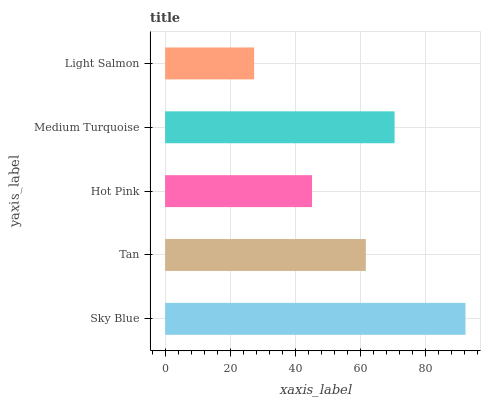Is Light Salmon the minimum?
Answer yes or no. Yes. Is Sky Blue the maximum?
Answer yes or no. Yes. Is Tan the minimum?
Answer yes or no. No. Is Tan the maximum?
Answer yes or no. No. Is Sky Blue greater than Tan?
Answer yes or no. Yes. Is Tan less than Sky Blue?
Answer yes or no. Yes. Is Tan greater than Sky Blue?
Answer yes or no. No. Is Sky Blue less than Tan?
Answer yes or no. No. Is Tan the high median?
Answer yes or no. Yes. Is Tan the low median?
Answer yes or no. Yes. Is Light Salmon the high median?
Answer yes or no. No. Is Sky Blue the low median?
Answer yes or no. No. 